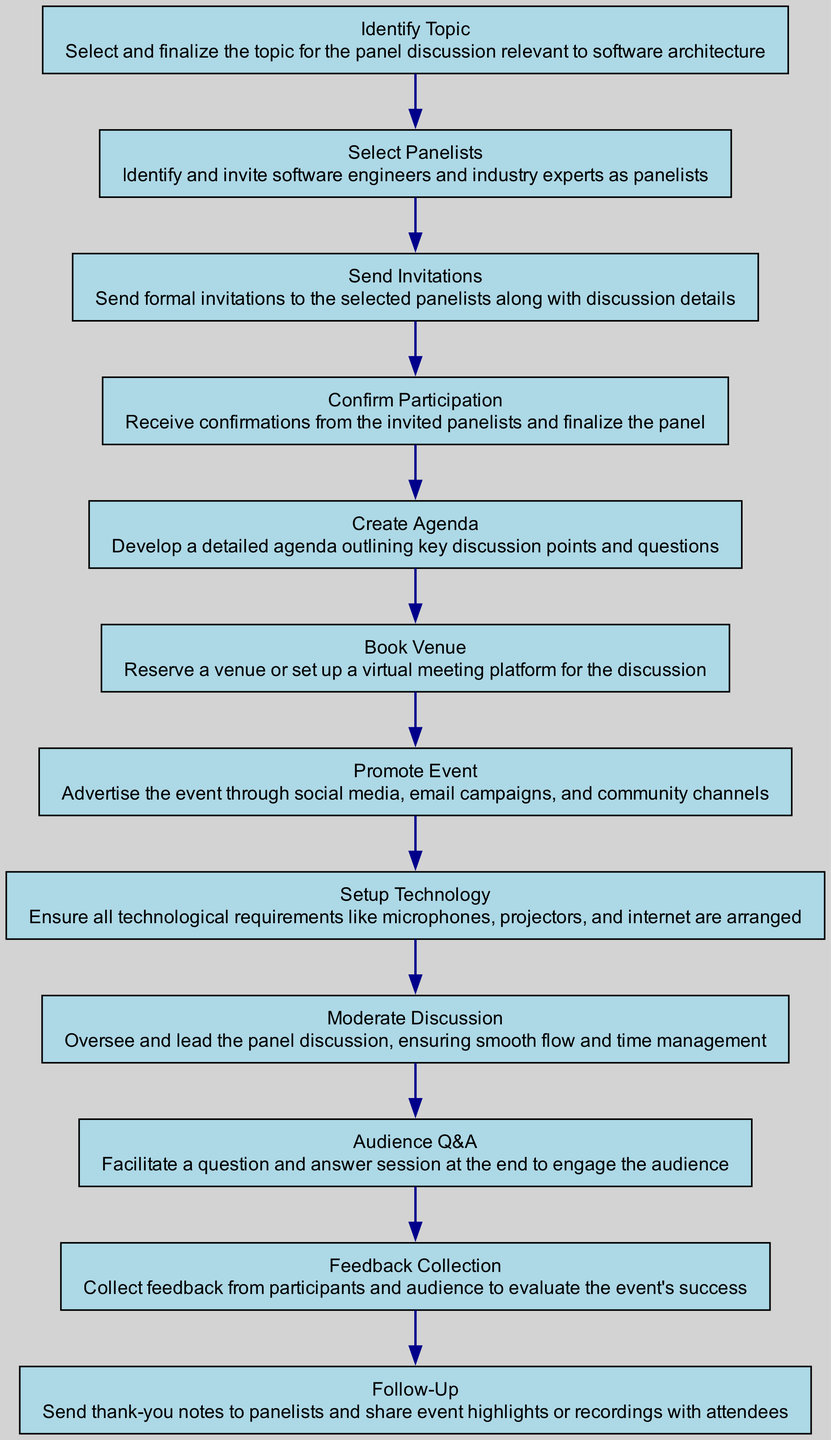What is the first step in the panel discussion process? The diagram indicates that the first step is to "Identify Topic", which involves selecting and finalizing the topic relevant to software architecture.
Answer: Identify Topic How many nodes are there in the diagram? By counting the elements listed in the diagram, there are a total of 12 distinct nodes that represent different steps in the process.
Answer: 12 What step comes after "Send Invitations"? The diagram shows that the next step after "Send Invitations" is "Confirm Participation", indicating that receiving confirmations from the invited panelists is necessary before finalizing the panel.
Answer: Confirm Participation Which step is responsible for engaging the audience? The "Audience Q&A" step in the diagram is designated to facilitate a question and answer session, which directly engages the audience at the end of the discussion.
Answer: Audience Q&A What is the last action taken in the diagram? The last action depicted in the flow chart is "Follow-Up", which involves sending thank-you notes to the panelists and sharing event highlights or recordings with the attendees.
Answer: Follow-Up Which two steps result in confirmations before proceeding? The steps "Send Invitations" and "Confirm Participation" are directly related; the first step involves sending invitations, and the second step follows by confirming whether the invited panelists will participate.
Answer: Send Invitations and Confirm Participation What do you need to do after creating the agenda? According to the diagram, after "Create Agenda", the next step is to "Book Venue", which involves reserving a physical or virtual space for the discussion.
Answer: Book Venue What aspect of the event does "Feedback Collection" address? "Feedback Collection" aims to evaluate the event's success by gathering insights from participants and the audience about their experiences during the panel discussion.
Answer: Evaluate event's success 